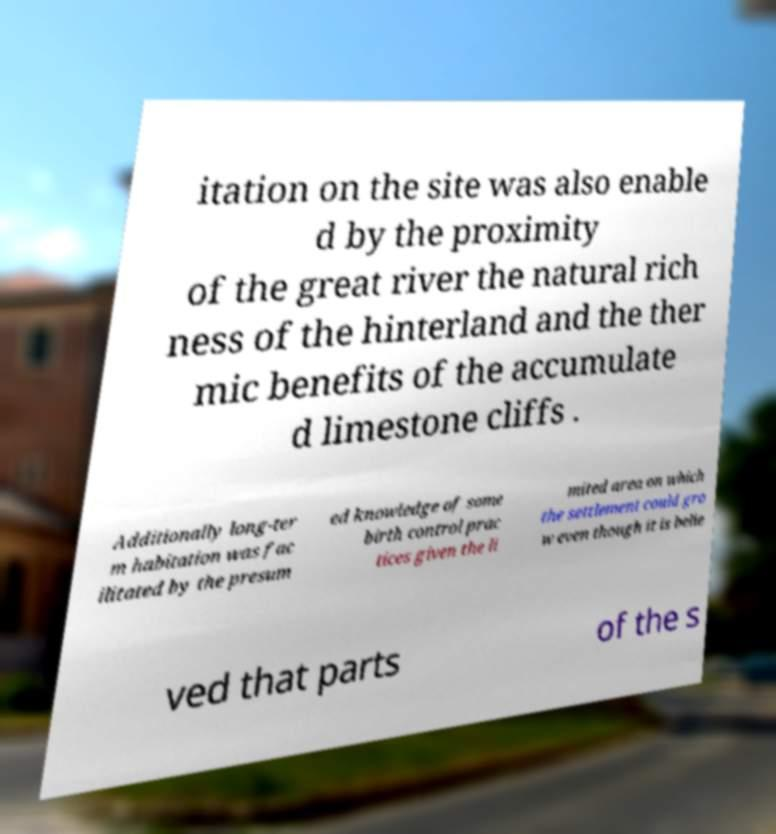Please identify and transcribe the text found in this image. itation on the site was also enable d by the proximity of the great river the natural rich ness of the hinterland and the ther mic benefits of the accumulate d limestone cliffs . Additionally long-ter m habitation was fac ilitated by the presum ed knowledge of some birth control prac tices given the li mited area on which the settlement could gro w even though it is belie ved that parts of the s 